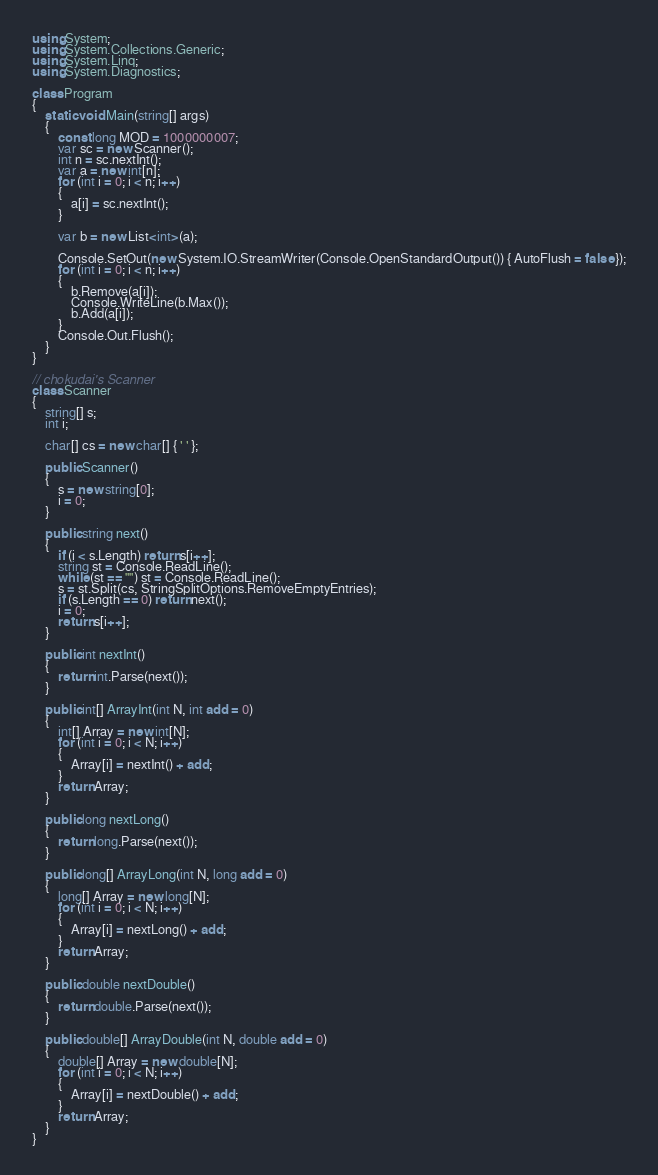Convert code to text. <code><loc_0><loc_0><loc_500><loc_500><_C#_>using System;
using System.Collections.Generic;
using System.Linq;
using System.Diagnostics;

class Program
{
    static void Main(string[] args)
    {
        const long MOD = 1000000007;
        var sc = new Scanner();
        int n = sc.nextInt();
        var a = new int[n];
        for (int i = 0; i < n; i++)
        {
            a[i] = sc.nextInt();
        }

        var b = new List<int>(a);

        Console.SetOut(new System.IO.StreamWriter(Console.OpenStandardOutput()) { AutoFlush = false });
        for (int i = 0; i < n; i++)
        {
            b.Remove(a[i]);
            Console.WriteLine(b.Max());
            b.Add(a[i]);
        }
        Console.Out.Flush();
    }
}

// chokudai's Scanner
class Scanner
{
    string[] s;
    int i;

    char[] cs = new char[] { ' ' };

    public Scanner()
    {
        s = new string[0];
        i = 0;
    }

    public string next()
    {
        if (i < s.Length) return s[i++];
        string st = Console.ReadLine();
        while (st == "") st = Console.ReadLine();
        s = st.Split(cs, StringSplitOptions.RemoveEmptyEntries);
        if (s.Length == 0) return next();
        i = 0;
        return s[i++];
    }

    public int nextInt()
    {
        return int.Parse(next());
    }

    public int[] ArrayInt(int N, int add = 0)
    {
        int[] Array = new int[N];
        for (int i = 0; i < N; i++)
        {
            Array[i] = nextInt() + add;
        }
        return Array;
    }

    public long nextLong()
    {
        return long.Parse(next());
    }

    public long[] ArrayLong(int N, long add = 0)
    {
        long[] Array = new long[N];
        for (int i = 0; i < N; i++)
        {
            Array[i] = nextLong() + add;
        }
        return Array;
    }

    public double nextDouble()
    {
        return double.Parse(next());
    }

    public double[] ArrayDouble(int N, double add = 0)
    {
        double[] Array = new double[N];
        for (int i = 0; i < N; i++)
        {
            Array[i] = nextDouble() + add;
        }
        return Array;
    }
}</code> 